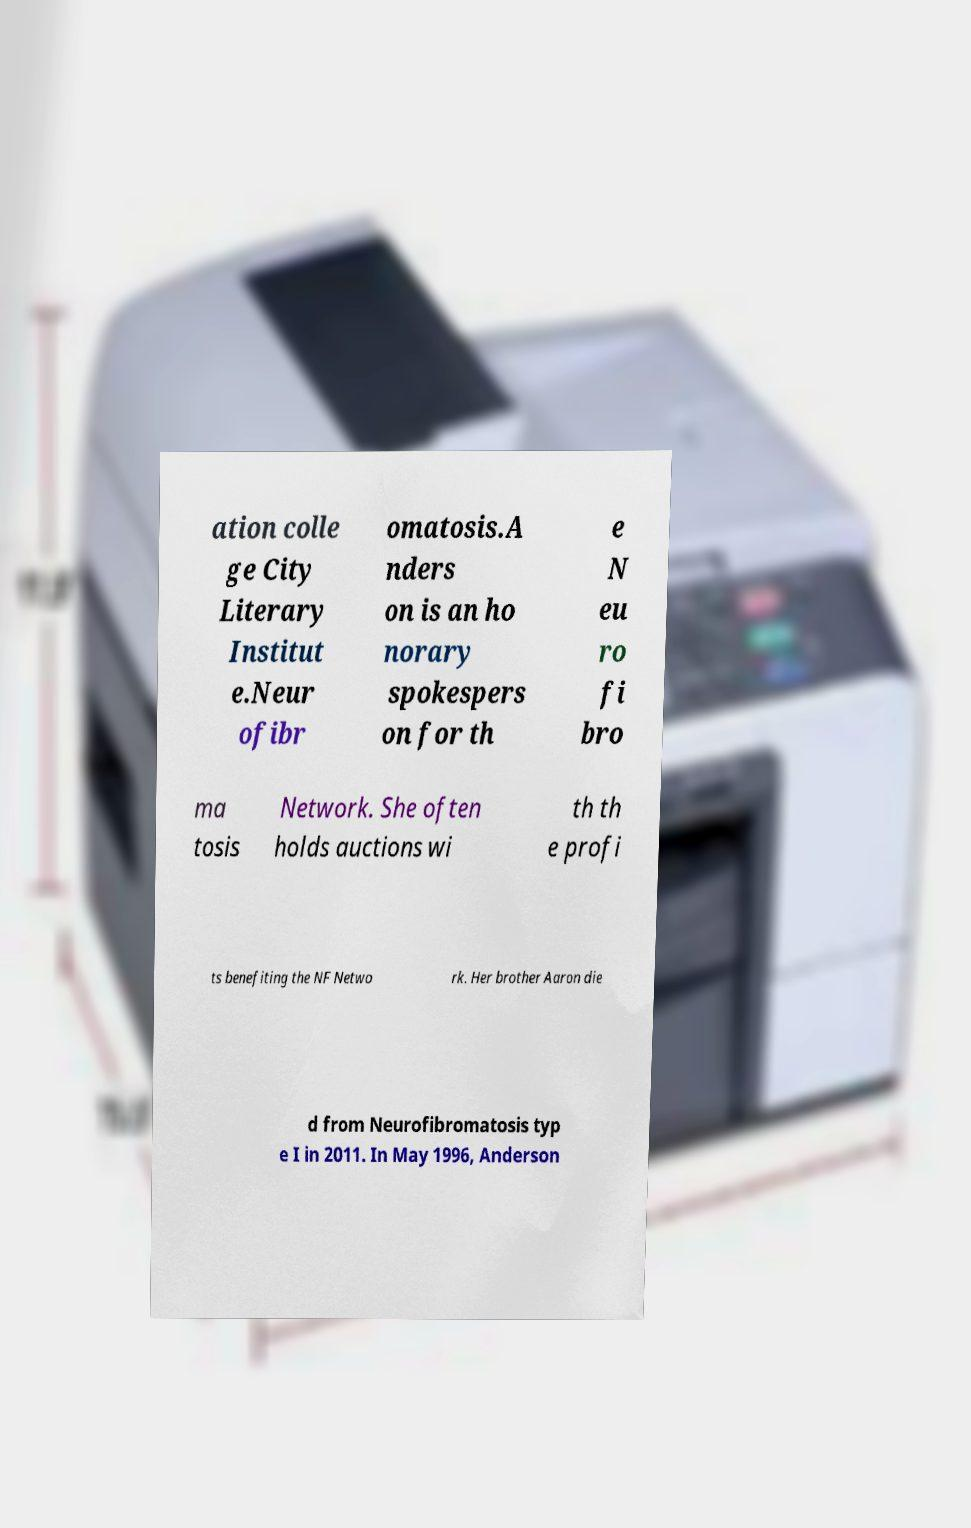Could you assist in decoding the text presented in this image and type it out clearly? ation colle ge City Literary Institut e.Neur ofibr omatosis.A nders on is an ho norary spokespers on for th e N eu ro fi bro ma tosis Network. She often holds auctions wi th th e profi ts benefiting the NF Netwo rk. Her brother Aaron die d from Neurofibromatosis typ e I in 2011. In May 1996, Anderson 